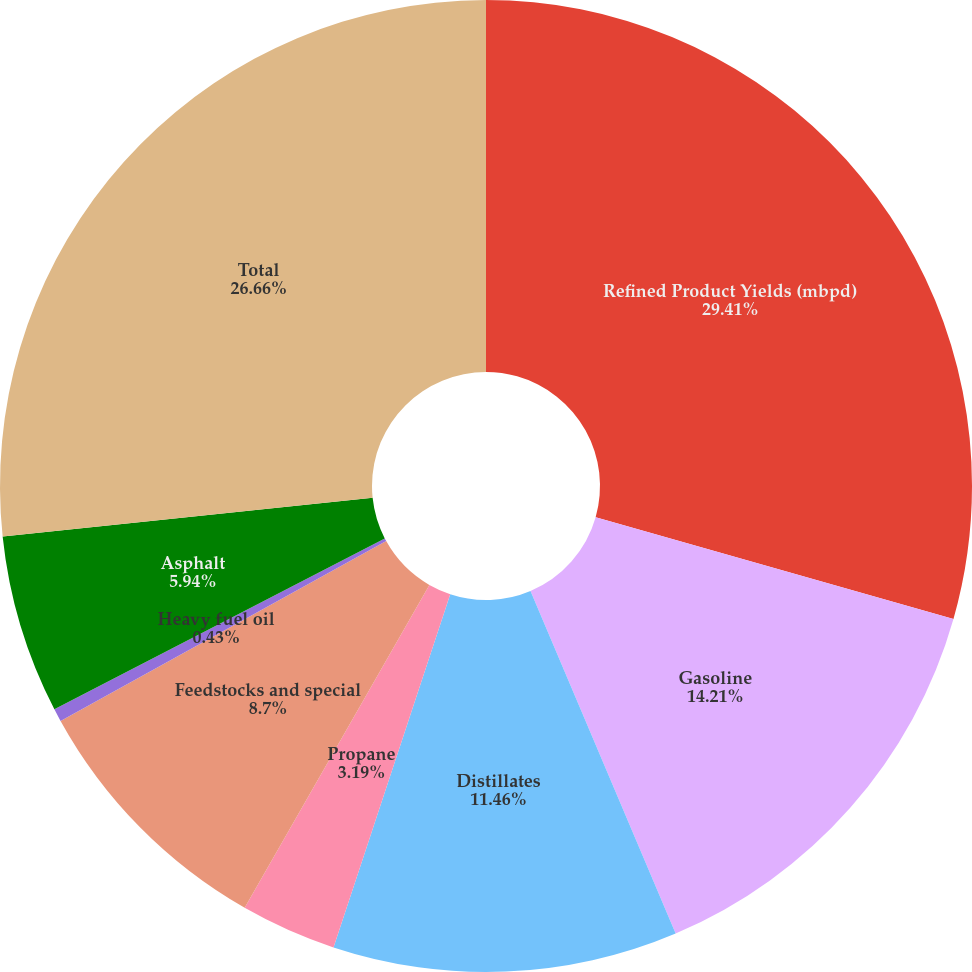Convert chart to OTSL. <chart><loc_0><loc_0><loc_500><loc_500><pie_chart><fcel>Refined Product Yields (mbpd)<fcel>Gasoline<fcel>Distillates<fcel>Propane<fcel>Feedstocks and special<fcel>Heavy fuel oil<fcel>Asphalt<fcel>Total<nl><fcel>29.41%<fcel>14.21%<fcel>11.46%<fcel>3.19%<fcel>8.7%<fcel>0.43%<fcel>5.94%<fcel>26.66%<nl></chart> 